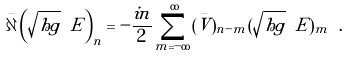Convert formula to latex. <formula><loc_0><loc_0><loc_500><loc_500>\bar { \partial } \left ( \sqrt { h g } \ E \right ) _ { n } = - \frac { i n } { 2 } \sum _ { m = - \infty } ^ { \infty } ( \bar { V } ) _ { n - m } ( \sqrt { h g } \ E ) _ { m } \ .</formula> 